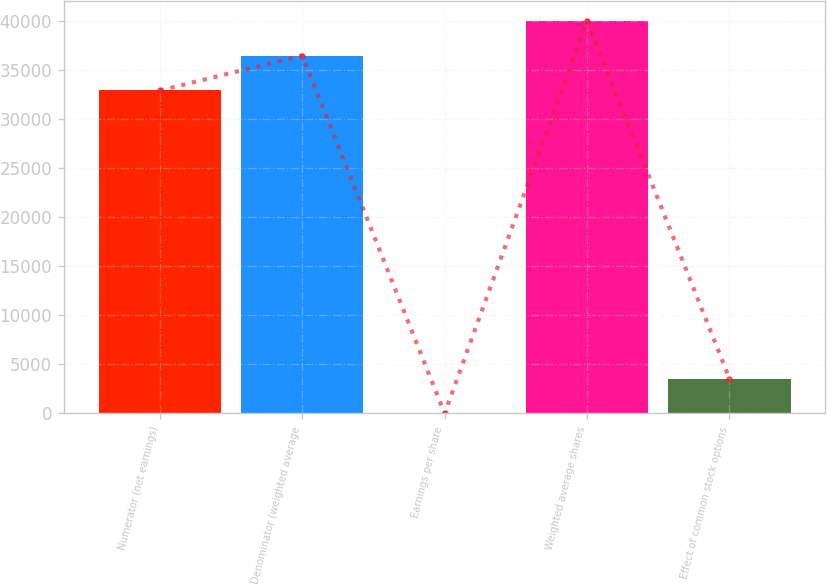Convert chart. <chart><loc_0><loc_0><loc_500><loc_500><bar_chart><fcel>Numerator (net earnings)<fcel>Denominator (weighted average<fcel>Earnings per share<fcel>Weighted average shares<fcel>Effect of common stock options<nl><fcel>32945<fcel>36505.1<fcel>0.93<fcel>40065.2<fcel>3561.04<nl></chart> 